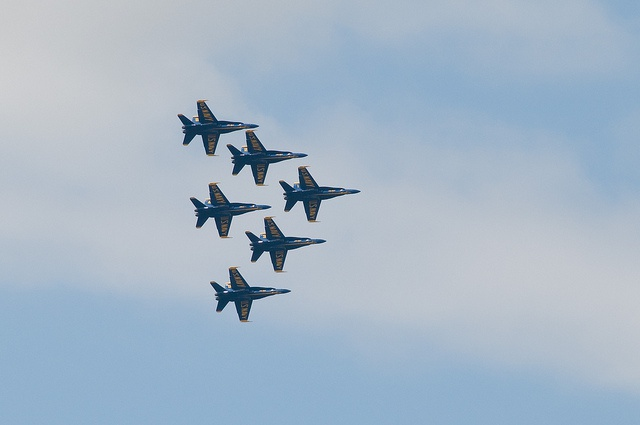Describe the objects in this image and their specific colors. I can see airplane in lightgray, darkblue, gray, blue, and darkgray tones, airplane in lightgray, navy, gray, blue, and darkgray tones, airplane in lightgray, darkblue, gray, blue, and navy tones, airplane in lightgray, darkblue, gray, blue, and navy tones, and airplane in lightgray, darkblue, gray, blue, and navy tones in this image. 